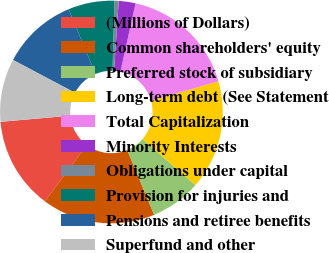<chart> <loc_0><loc_0><loc_500><loc_500><pie_chart><fcel>(Millions of Dollars)<fcel>Common shareholders' equity<fcel>Preferred stock of subsidiary<fcel>Long-term debt (See Statement<fcel>Total Capitalization<fcel>Minority Interests<fcel>Obligations under capital<fcel>Provision for injuries and<fcel>Pensions and retiree benefits<fcel>Superfund and other<nl><fcel>13.41%<fcel>16.46%<fcel>7.32%<fcel>15.85%<fcel>17.07%<fcel>2.44%<fcel>0.61%<fcel>6.71%<fcel>10.98%<fcel>9.15%<nl></chart> 